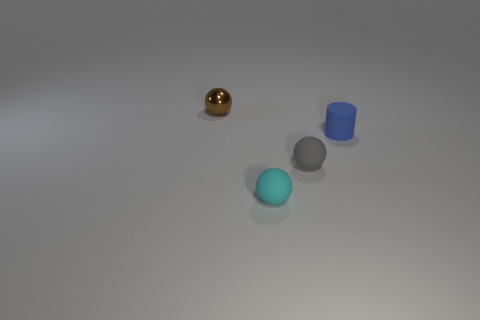Is there any other thing that has the same material as the small brown object?
Offer a terse response. No. There is a rubber thing that is in front of the gray matte thing; is its shape the same as the gray rubber object?
Keep it short and to the point. Yes. What color is the metallic sphere?
Offer a terse response. Brown. Is there a big blue cylinder?
Provide a succinct answer. No. There is a tiny thing that is behind the tiny rubber object on the right side of the rubber ball behind the cyan thing; what is its shape?
Ensure brevity in your answer.  Sphere. Is the number of brown objects that are on the right side of the small cylinder the same as the number of cyan shiny cylinders?
Provide a short and direct response. Yes. Is the shape of the tiny gray matte object the same as the tiny blue object?
Your answer should be very brief. No. How many objects are either objects that are behind the tiny matte cylinder or brown objects?
Offer a very short reply. 1. Is the number of small cyan matte balls on the left side of the cyan thing the same as the number of small brown things that are behind the small rubber cylinder?
Ensure brevity in your answer.  No. What number of other things are the same shape as the tiny metal object?
Your answer should be compact. 2. 